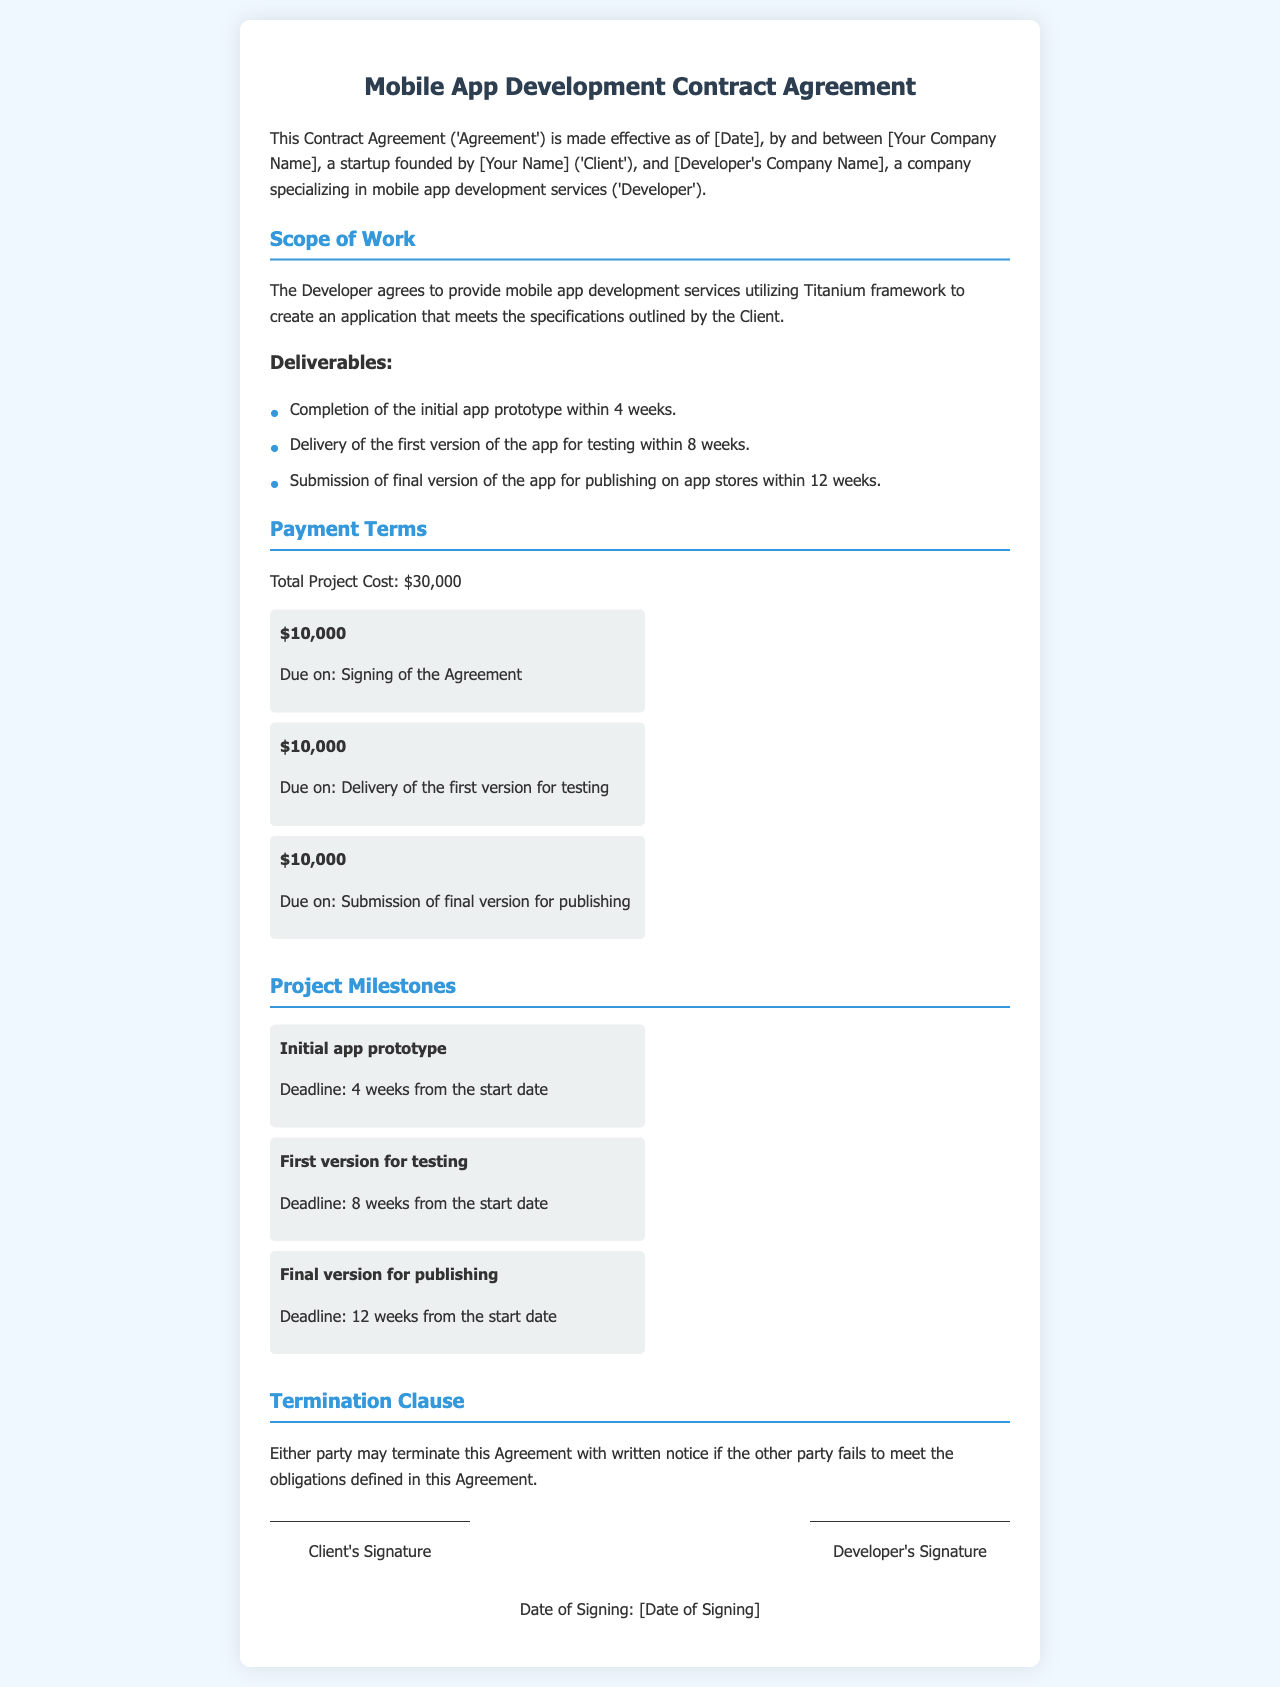What is the total project cost? The total project cost is specified in the payment terms section of the document, amounting to thirty thousand dollars.
Answer: $30,000 When is the initial app prototype due? The deadline for the initial app prototype is mentioned in the project milestones section, due within four weeks from the start date.
Answer: 4 weeks What is the last payment amount? The last payment amount is stated in the payment terms section as due upon submission of the final version for publishing.
Answer: $10,000 What is the second milestone in the project? The second milestone outlined in the project milestones section is the first version for testing.
Answer: First version for testing How can either party terminate the agreement? The document specifies that either party may terminate the agreement with written notice if the other party fails to meet obligations.
Answer: Written notice Who is the client in the agreement? The client's name is found in the introduction of the document as the startup founder by the specified name, along with the company name.
Answer: [Your Company Name] 